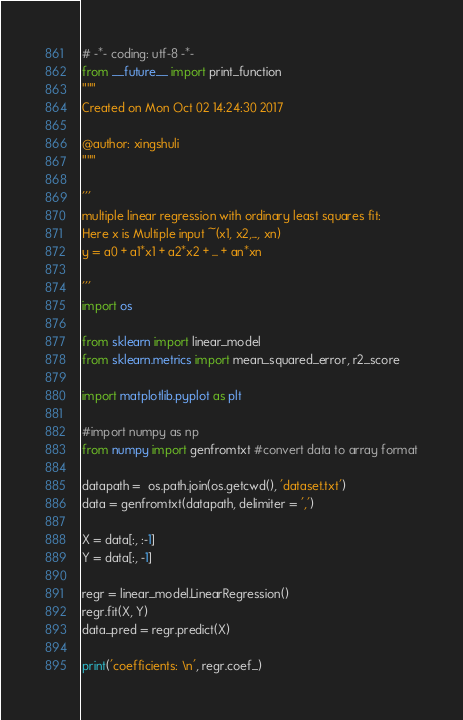<code> <loc_0><loc_0><loc_500><loc_500><_Python_># -*- coding: utf-8 -*-
from __future__ import print_function
"""
Created on Mon Oct 02 14:24:30 2017

@author: xingshuli
"""

'''
multiple linear regression with ordinary least squares fit: 
Here x is Multiple input ~(x1, x2,..., xn)
y = a0 + a1*x1 + a2*x2 + ... + an*xn

'''
import os 

from sklearn import linear_model
from sklearn.metrics import mean_squared_error, r2_score

import matplotlib.pyplot as plt

#import numpy as np
from numpy import genfromtxt #convert data to array format

datapath =  os.path.join(os.getcwd(), 'dataset.txt')
data = genfromtxt(datapath, delimiter = ',')

X = data[:, :-1]
Y = data[:, -1]

regr = linear_model.LinearRegression()
regr.fit(X, Y)
data_pred = regr.predict(X)

print('coefficients: \n', regr.coef_)
</code> 